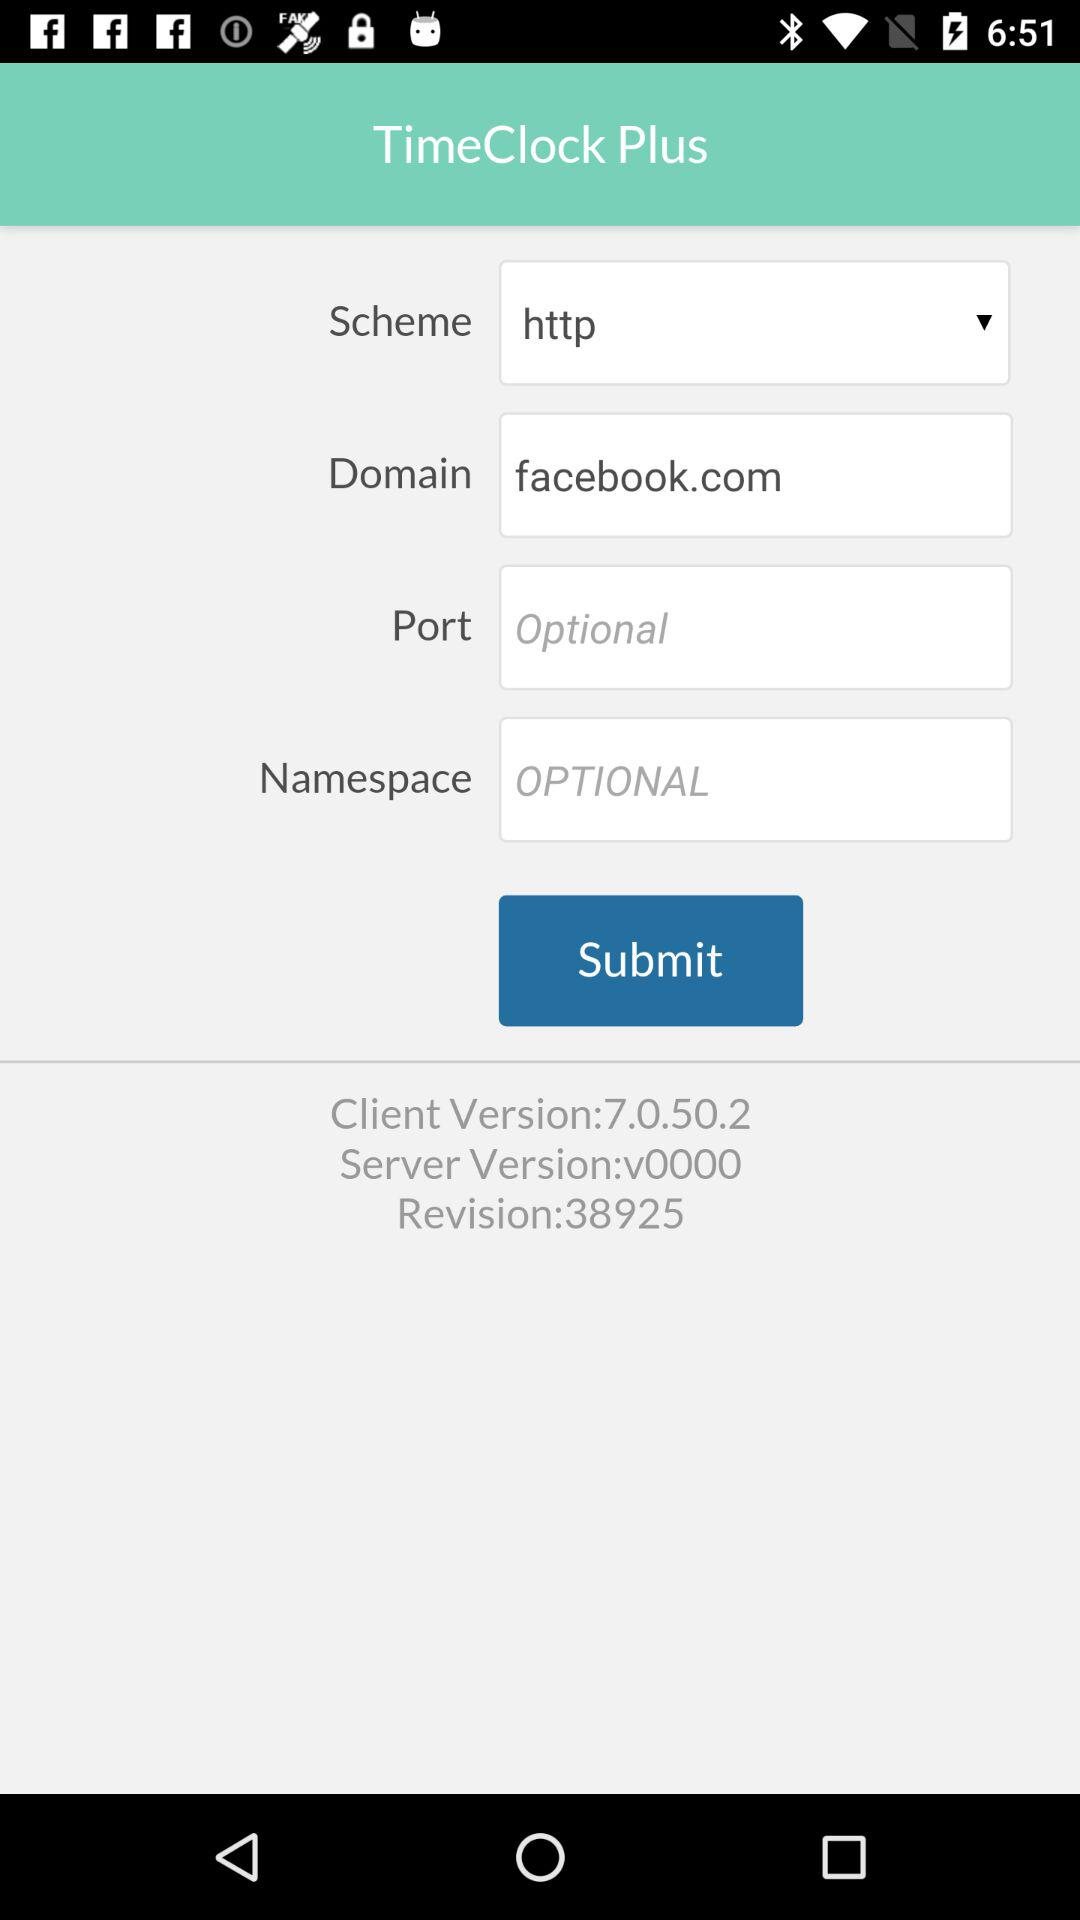What is the revision? The revision is 38925. 